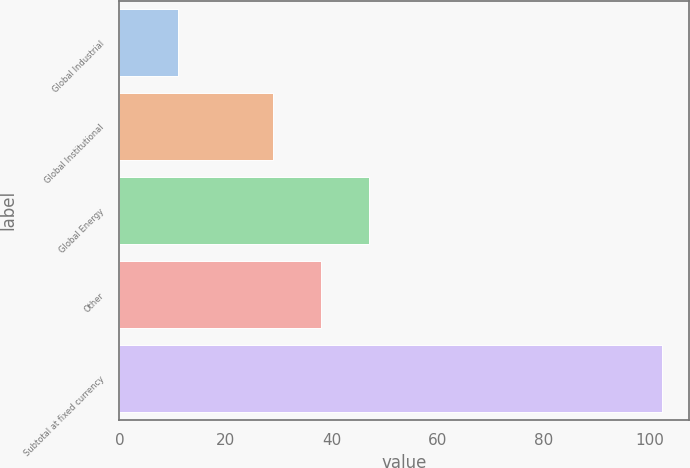Convert chart to OTSL. <chart><loc_0><loc_0><loc_500><loc_500><bar_chart><fcel>Global Industrial<fcel>Global Institutional<fcel>Global Energy<fcel>Other<fcel>Subtotal at fixed currency<nl><fcel>11<fcel>28.9<fcel>47.16<fcel>38.03<fcel>102.3<nl></chart> 